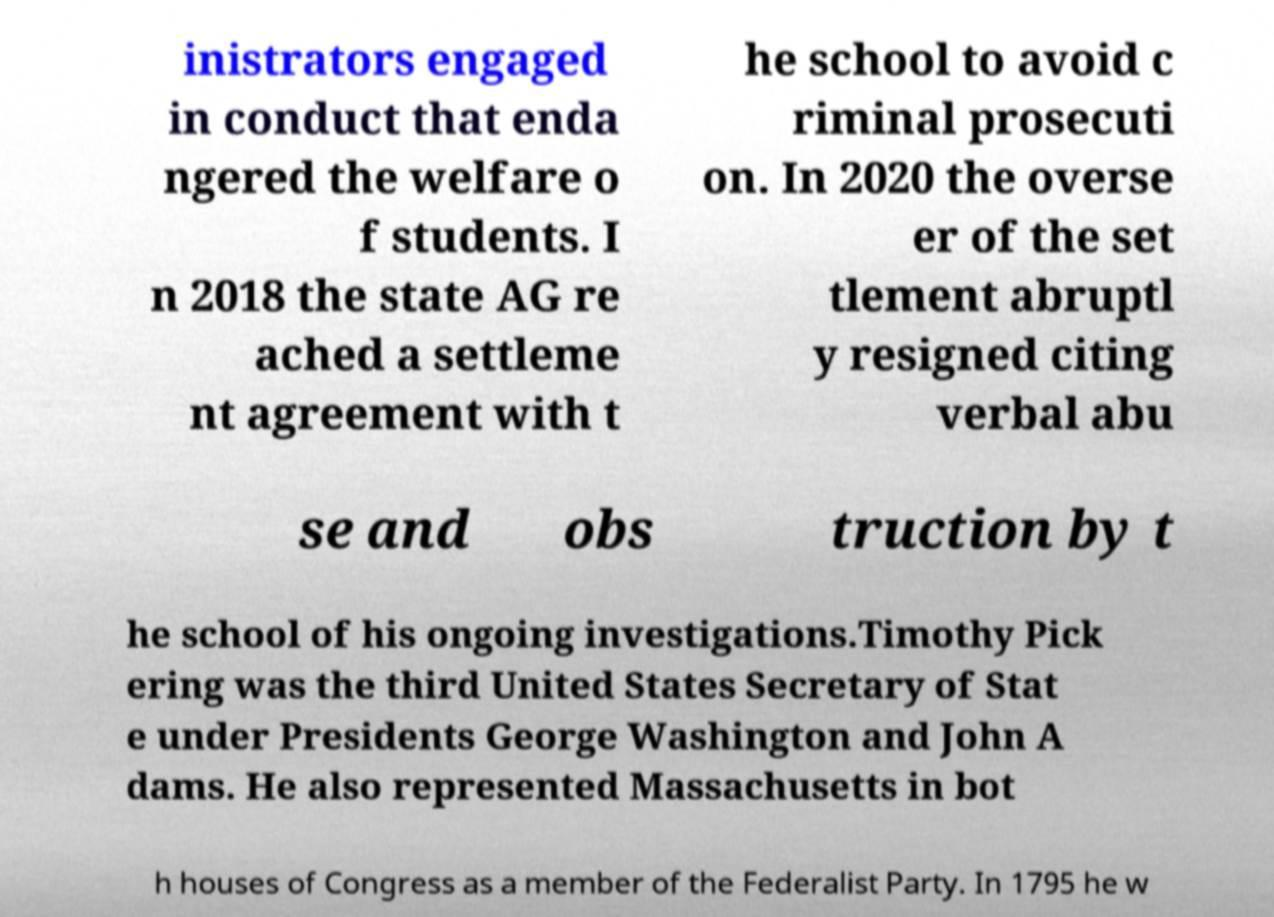Please read and relay the text visible in this image. What does it say? inistrators engaged in conduct that enda ngered the welfare o f students. I n 2018 the state AG re ached a settleme nt agreement with t he school to avoid c riminal prosecuti on. In 2020 the overse er of the set tlement abruptl y resigned citing verbal abu se and obs truction by t he school of his ongoing investigations.Timothy Pick ering was the third United States Secretary of Stat e under Presidents George Washington and John A dams. He also represented Massachusetts in bot h houses of Congress as a member of the Federalist Party. In 1795 he w 